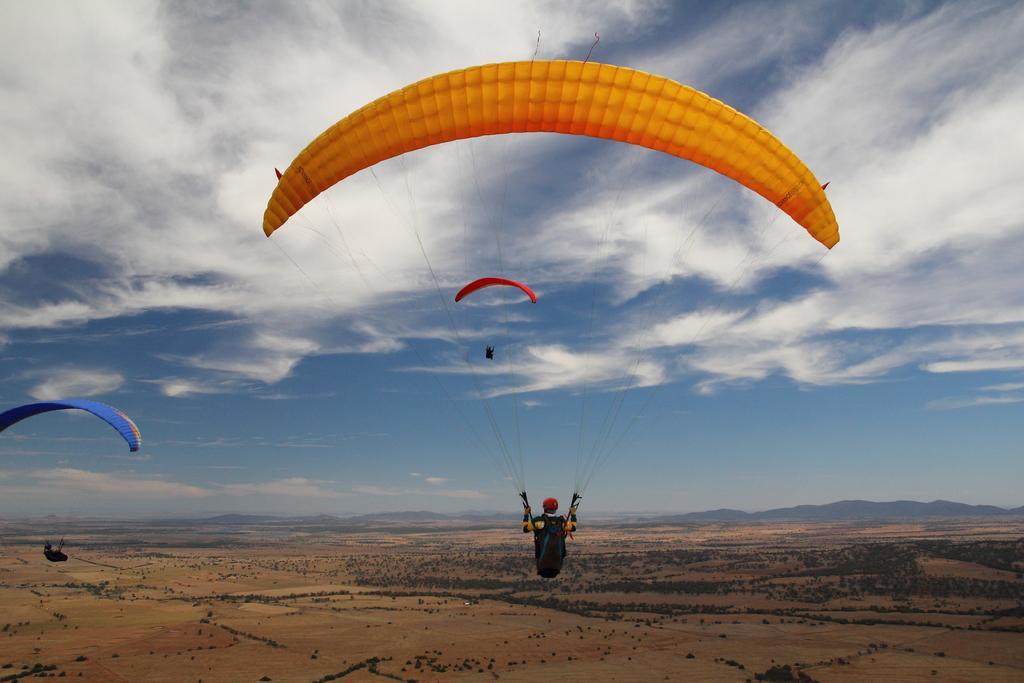Please provide a concise description of this image. In this picture we can observe some people parachuting. We can observe an orange, red and blue color parachutes. There are some trees on the ground. In the background there is a sky with some clouds. 